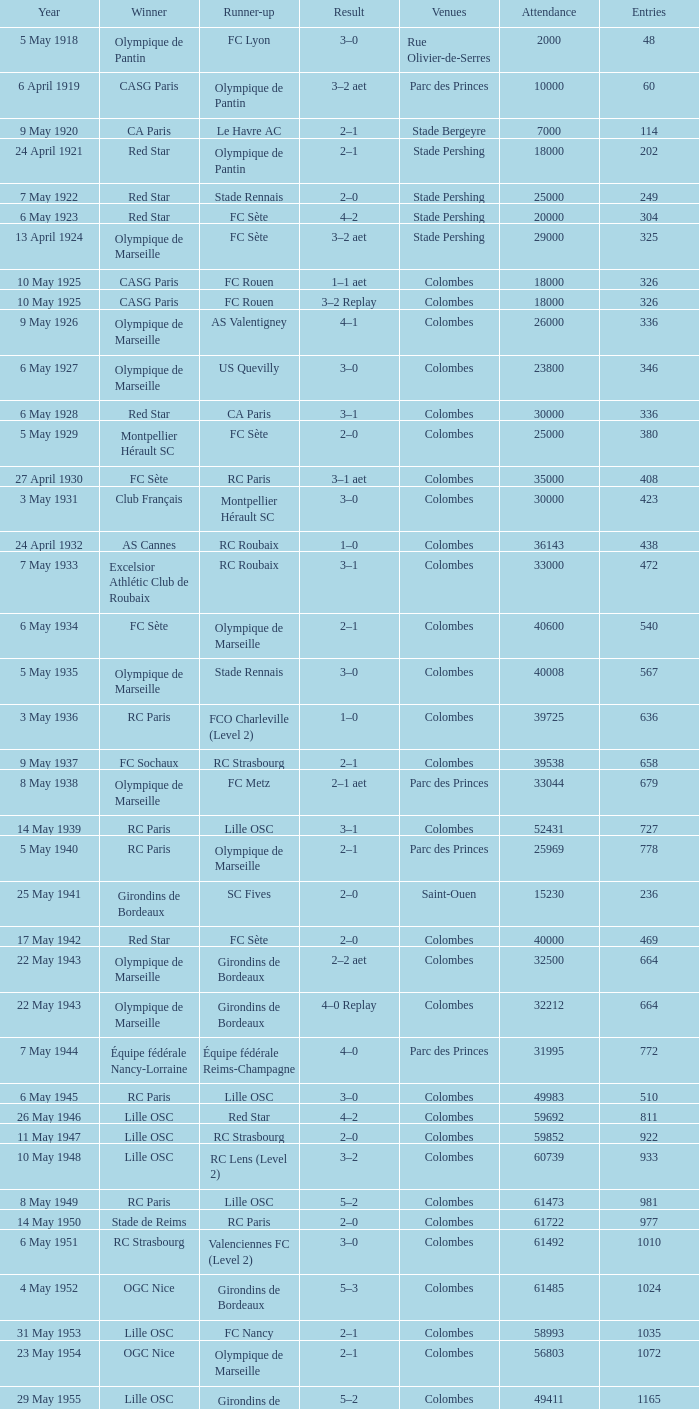What is the number of games where red star came in second place? 1.0. 